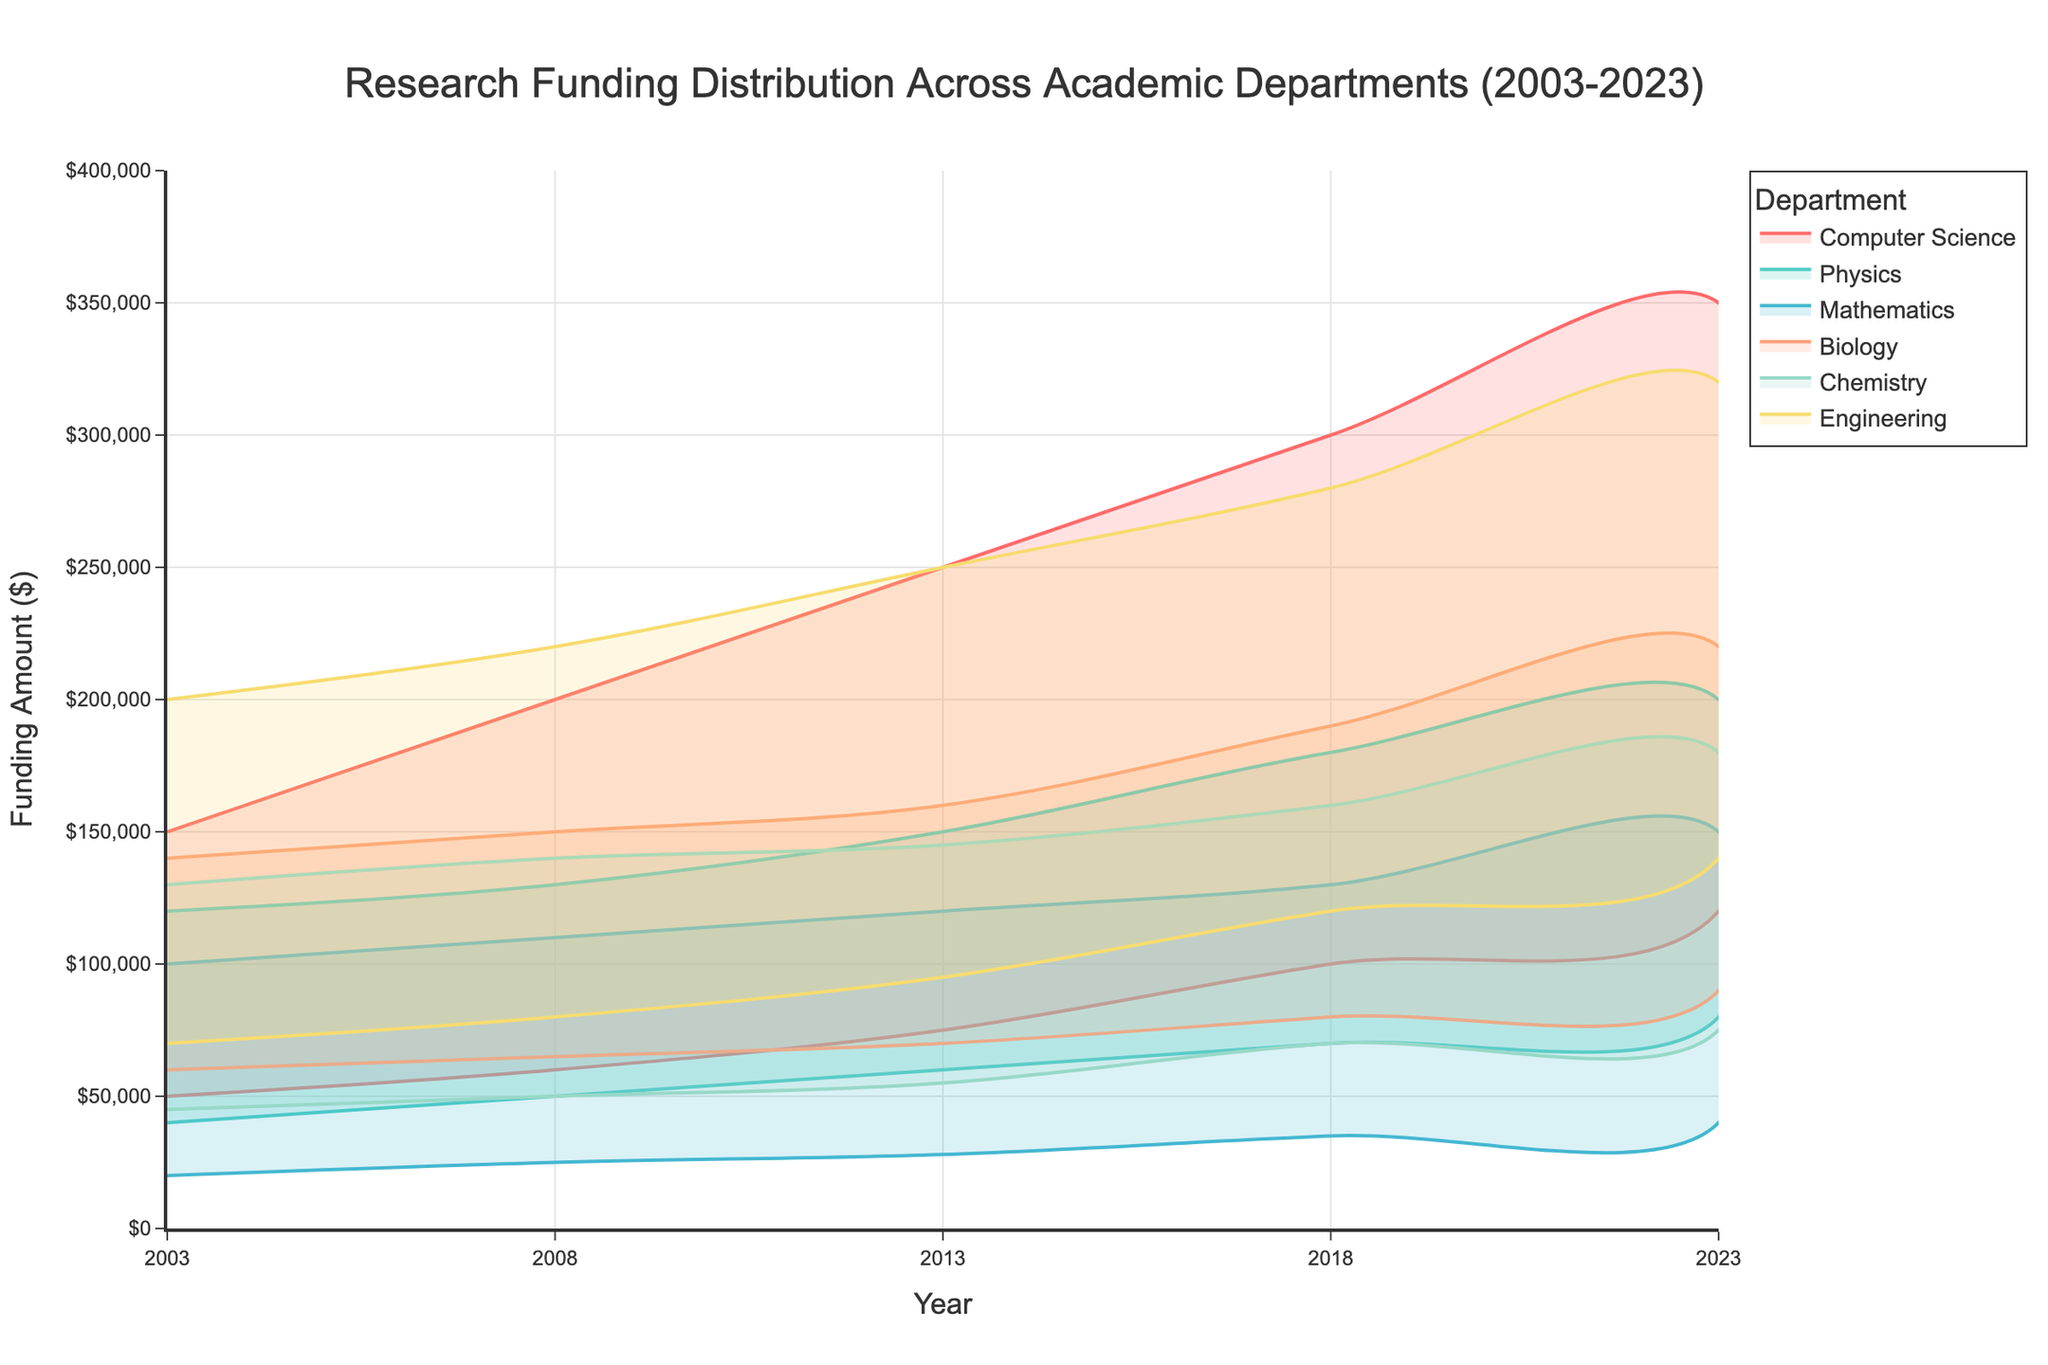What is the title of the chart? The title of the chart is displayed prominently at the top of the figure. The text inside the chart title usually gives a summarizing description of the data.
Answer: Research Funding Distribution Across Academic Departments (2003-2023) Which department had the highest maximum funding in 2003? By examining the range area for each department in 2003, we can see that the Engineering department has the highest maximum funding compared to others.
Answer: Engineering What was the range of funding for the Computer Science department in 2013? The chart displays the minimum and maximum funding for each department. For Computer Science in 2013, the minimum funding was $75,000 and the maximum funding was $250,000. The range is calculated as $250,000 - $75,000.
Answer: $175,000 Which department had the smallest increase in minimum funding from 2003 to 2023? To determine this, we need to look at the minimum funding values for each department in 2003 and 2023. Then, we'll calculate the difference for each department. Comparing these differences, the Mathematics department shows the smallest increase from $20,000 to $40,000.
Answer: Mathematics By how much did the maximum funding for the Biology department increase from 2003 to 2023? Locate the maximum funding values for the Biology department in 2003 and 2023 from the chart. In 2003, it is $140,000; in 2023, it is $220,000. The increase is calculated as $220,000 - $140,000.
Answer: $80,000 Which department consistently had the highest minimum funding throughout the given years? By observing the ranges for each department at every given year, it's clear that the Engineering department had the highest minimum funding in all cases.
Answer: Engineering What department saw the most significant increase in maximum funding between 2008 and 2018? This requires comparing the spikes in maximum funding for each department between 2008 and 2018. The Computer Science department saw the most significant increase from $200,000 to $300,000.
Answer: Computer Science How did the range of funding for the Chemistry department change from 2003 to 2023? We need to calculate the range (Max - Min) for Chemistry in 2003 and 2023, then compare them. For 2003: $130,000 - $45,000 = $85,000; for 2023: $180,000 - $75,000 = $105,000. The change is $105,000 - $85,000.
Answer: $20,000 increase Which department had the narrowest funding range in 2023? To determine this, observe all departments' funding ranges in 2023 and find the smallest one. For Mathematics, the range is calculated as $150,000 - $40,000.
Answer: Mathematics ($110,000) Did any department's minimum funding ever surpass another department's maximum funding within the same year? By cross-referencing the ranges for each year visually, we can confirm that there is no instance where a minimum funding value from one department exceeds the maximum funding value of another department.
Answer: No 